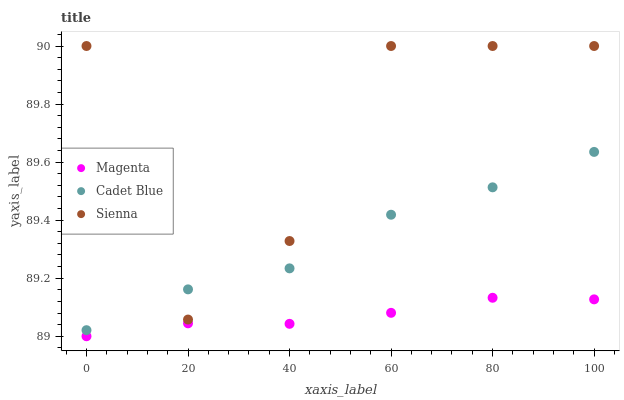Does Magenta have the minimum area under the curve?
Answer yes or no. Yes. Does Sienna have the maximum area under the curve?
Answer yes or no. Yes. Does Cadet Blue have the minimum area under the curve?
Answer yes or no. No. Does Cadet Blue have the maximum area under the curve?
Answer yes or no. No. Is Magenta the smoothest?
Answer yes or no. Yes. Is Sienna the roughest?
Answer yes or no. Yes. Is Cadet Blue the smoothest?
Answer yes or no. No. Is Cadet Blue the roughest?
Answer yes or no. No. Does Magenta have the lowest value?
Answer yes or no. Yes. Does Cadet Blue have the lowest value?
Answer yes or no. No. Does Sienna have the highest value?
Answer yes or no. Yes. Does Cadet Blue have the highest value?
Answer yes or no. No. Is Magenta less than Sienna?
Answer yes or no. Yes. Is Cadet Blue greater than Magenta?
Answer yes or no. Yes. Does Cadet Blue intersect Sienna?
Answer yes or no. Yes. Is Cadet Blue less than Sienna?
Answer yes or no. No. Is Cadet Blue greater than Sienna?
Answer yes or no. No. Does Magenta intersect Sienna?
Answer yes or no. No. 